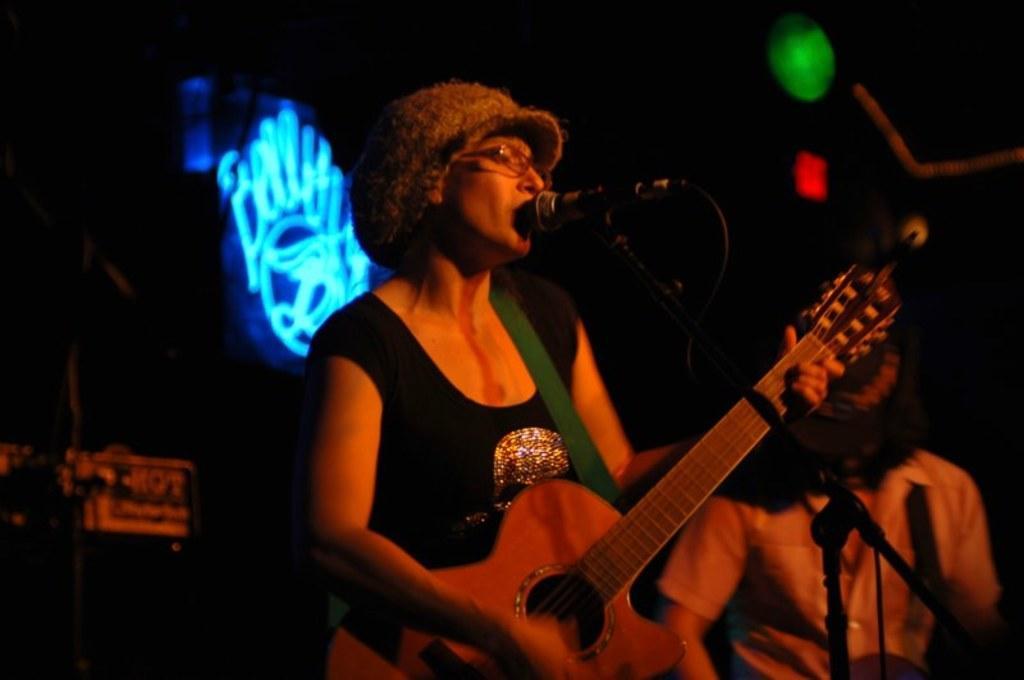In one or two sentences, can you explain what this image depicts? This picture shows a woman standing and playing guitar and singing with the help of a microphone and we see a man standing on the side and we see a light back of her 